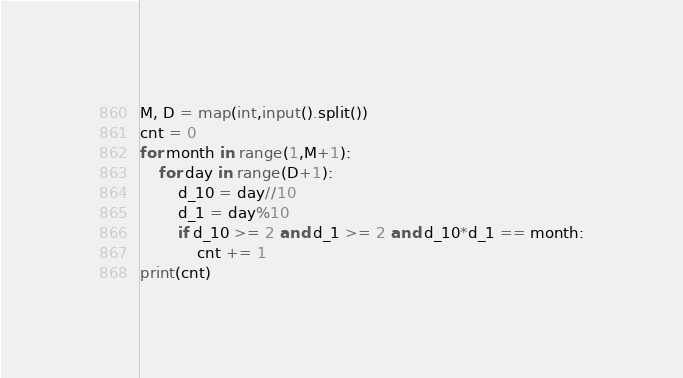<code> <loc_0><loc_0><loc_500><loc_500><_Python_>M, D = map(int,input().split())
cnt = 0
for month in range(1,M+1):
    for day in range(D+1):
        d_10 = day//10
        d_1 = day%10
        if d_10 >= 2 and d_1 >= 2 and d_10*d_1 == month:
            cnt += 1
print(cnt)</code> 